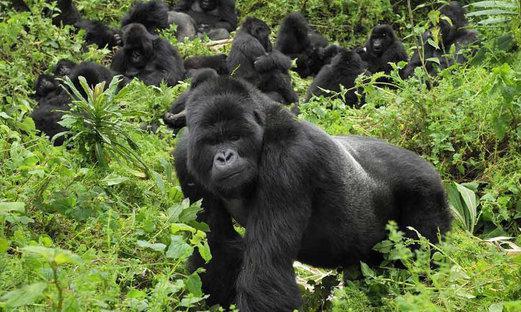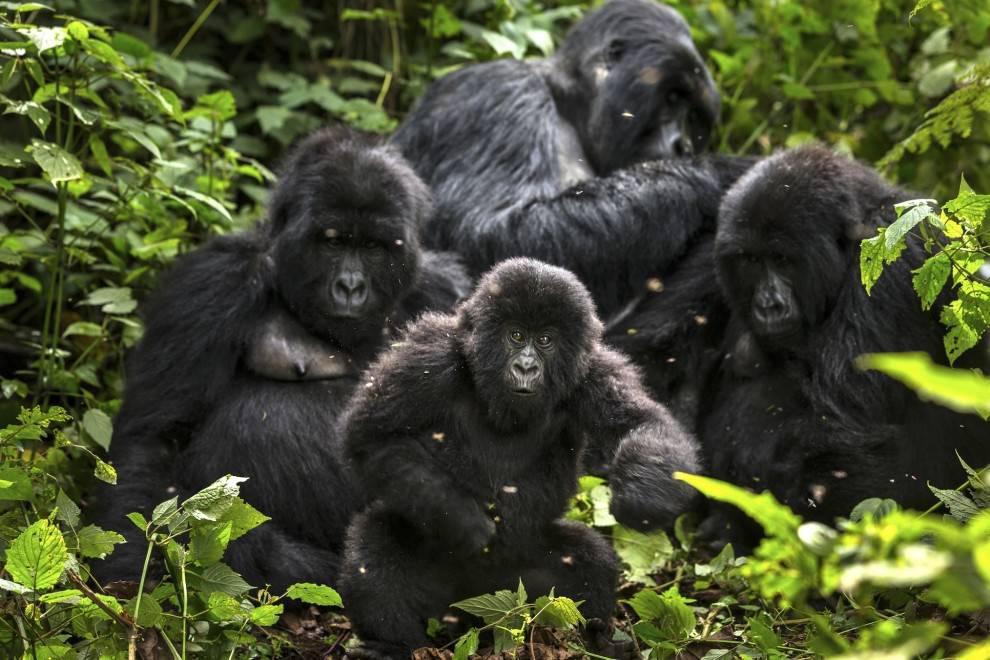The first image is the image on the left, the second image is the image on the right. Assess this claim about the two images: "An image shows exactly two furry apes wrestling each other, both with wide-open mouths.". Correct or not? Answer yes or no. No. The first image is the image on the left, the second image is the image on the right. Considering the images on both sides, is "to the left, two simians appear to be playfully irritated at each other." valid? Answer yes or no. No. 